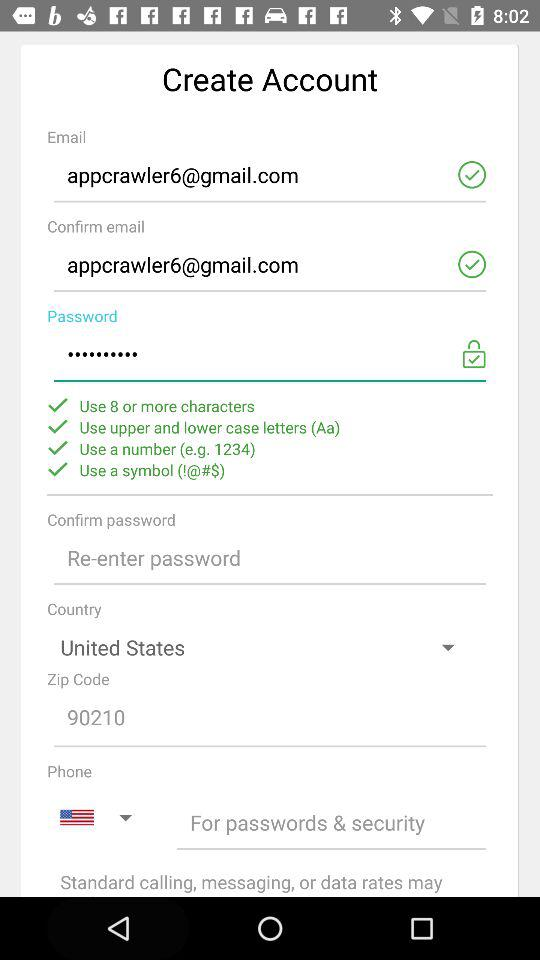What type of number can be use in Password?
When the provided information is insufficient, respond with <no answer>. <no answer> 